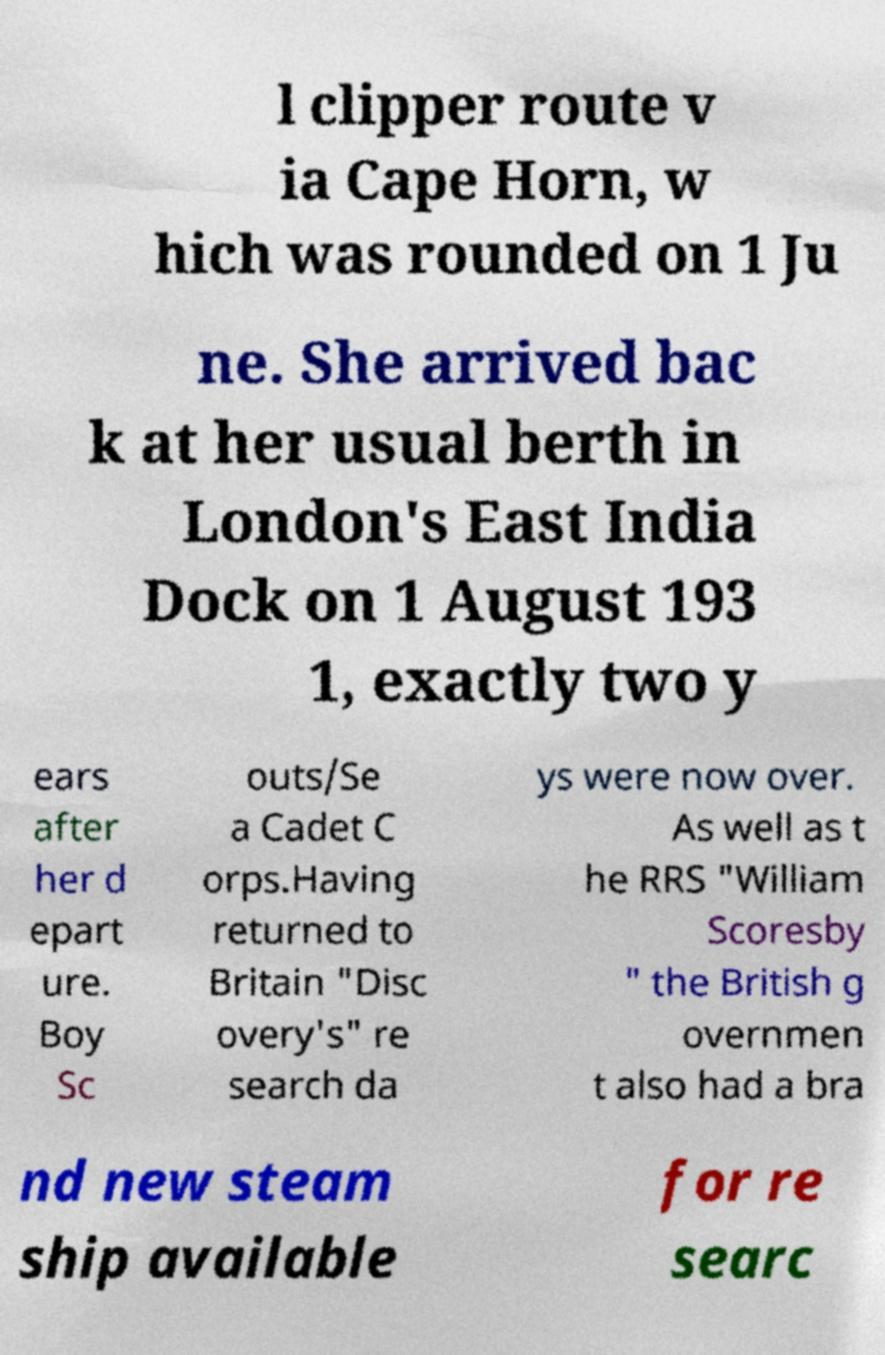Can you read and provide the text displayed in the image?This photo seems to have some interesting text. Can you extract and type it out for me? l clipper route v ia Cape Horn, w hich was rounded on 1 Ju ne. She arrived bac k at her usual berth in London's East India Dock on 1 August 193 1, exactly two y ears after her d epart ure. Boy Sc outs/Se a Cadet C orps.Having returned to Britain "Disc overy's" re search da ys were now over. As well as t he RRS "William Scoresby " the British g overnmen t also had a bra nd new steam ship available for re searc 